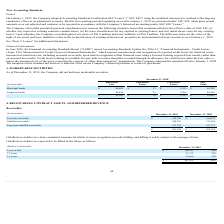According to Pegasystems's financial document, What does unbilled receivables refer to? Unbilled receivables are client committed amounts for which revenue recognition precedes billing. The document states: "Unbilled receivables are client committed amounts for which revenue recognition precedes billing, and billing is solely subject to the passage of time..." Also, What are the respective unbilled receivables within 1 year or less and within 1-2 years? The document shows two values: 180,219 and 91,132 (in thousands). From the document: "1-2 years 91,132 30% Unbilled receivables 180,219 172,656..." Also, What are the respective unbilled receivables within 1-2 years and within 2-5 years? The document shows two values: 91,132 and 30,604 (in thousands). From the document: "1-2 years 91,132 30% 2-5 years 30,604 10%..." Also, can you calculate: What is the total unbilled receivables due within 2 years? Based on the calculation: 180,219 + 91,132 , the result is 271351 (in thousands). This is based on the information: "1-2 years 91,132 30% Unbilled receivables 180,219 172,656..." The key data points involved are: 180,219, 91,132. Also, can you calculate: What is the total unbilled receivables due between 1 to 5 years? Based on the calculation: 91,132 + 30,604 , the result is 121736 (in thousands). This is based on the information: "1-2 years 91,132 30% 2-5 years 30,604 10%..." The key data points involved are: 30,604, 91,132. Also, can you calculate: What is the value of the unbilled receivables due within 2-5 years as a percentage of the unbilled receivables due within 1 year? Based on the calculation: 30,604/180,219 , the result is 16.98 (percentage). This is based on the information: "Unbilled receivables 180,219 172,656 2-5 years 30,604 10%..." The key data points involved are: 180,219, 30,604. 